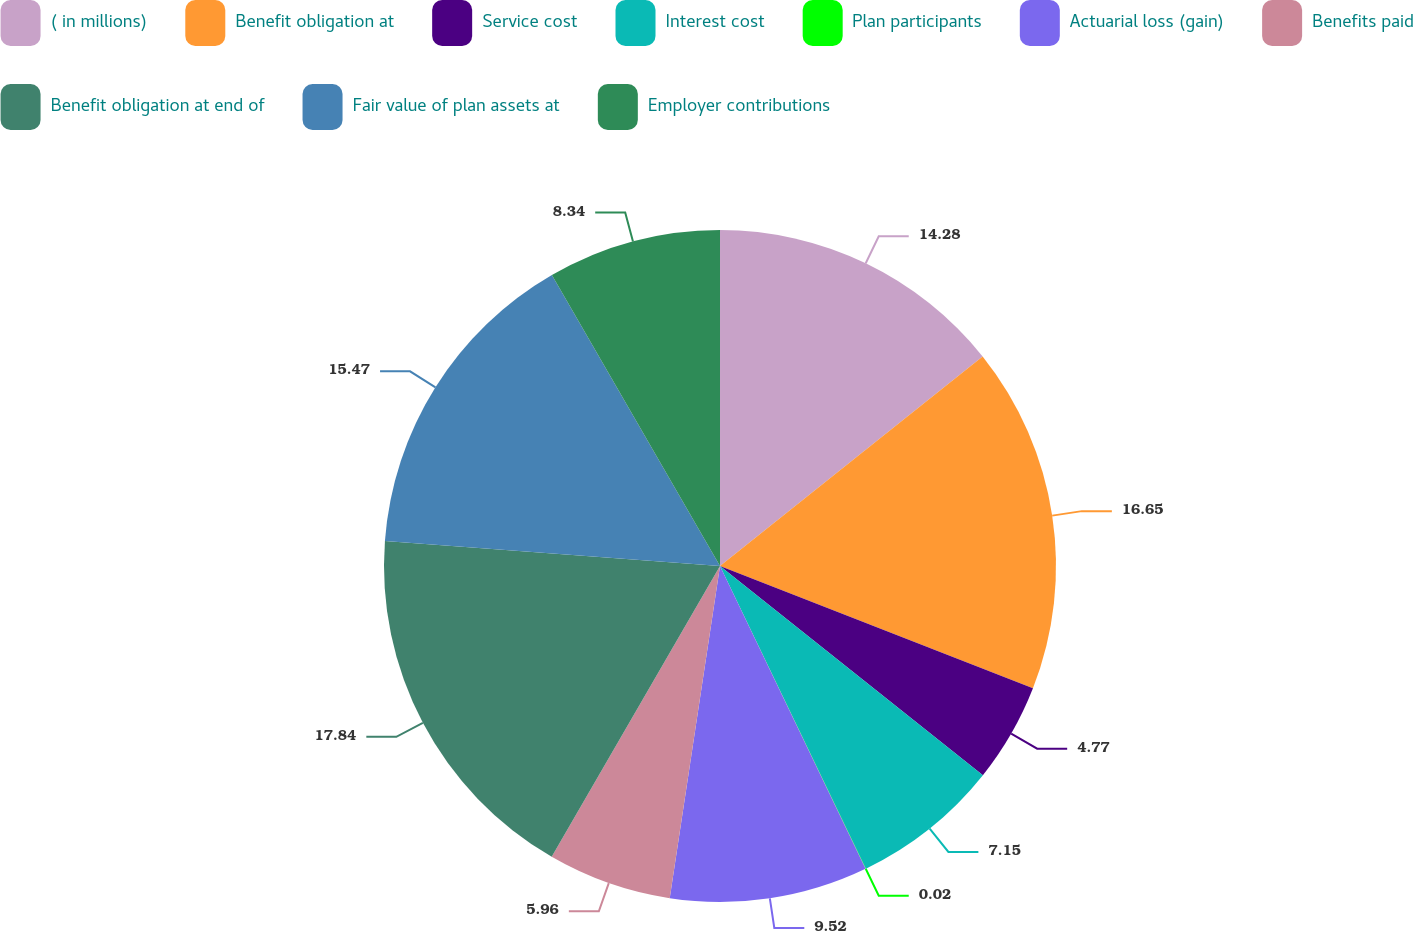<chart> <loc_0><loc_0><loc_500><loc_500><pie_chart><fcel>( in millions)<fcel>Benefit obligation at<fcel>Service cost<fcel>Interest cost<fcel>Plan participants<fcel>Actuarial loss (gain)<fcel>Benefits paid<fcel>Benefit obligation at end of<fcel>Fair value of plan assets at<fcel>Employer contributions<nl><fcel>14.28%<fcel>16.65%<fcel>4.77%<fcel>7.15%<fcel>0.02%<fcel>9.52%<fcel>5.96%<fcel>17.84%<fcel>15.47%<fcel>8.34%<nl></chart> 